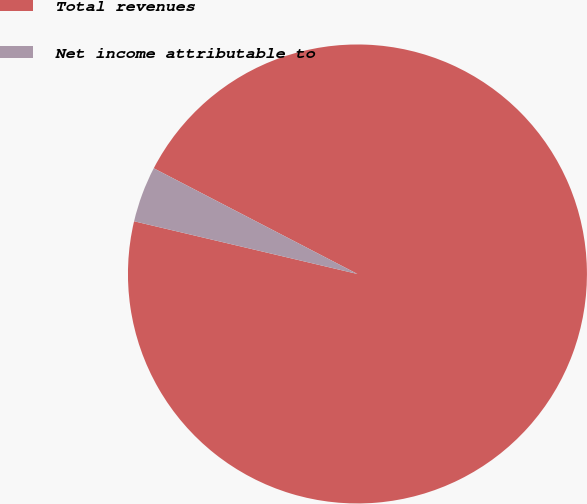Convert chart to OTSL. <chart><loc_0><loc_0><loc_500><loc_500><pie_chart><fcel>Total revenues<fcel>Net income attributable to<nl><fcel>96.07%<fcel>3.93%<nl></chart> 